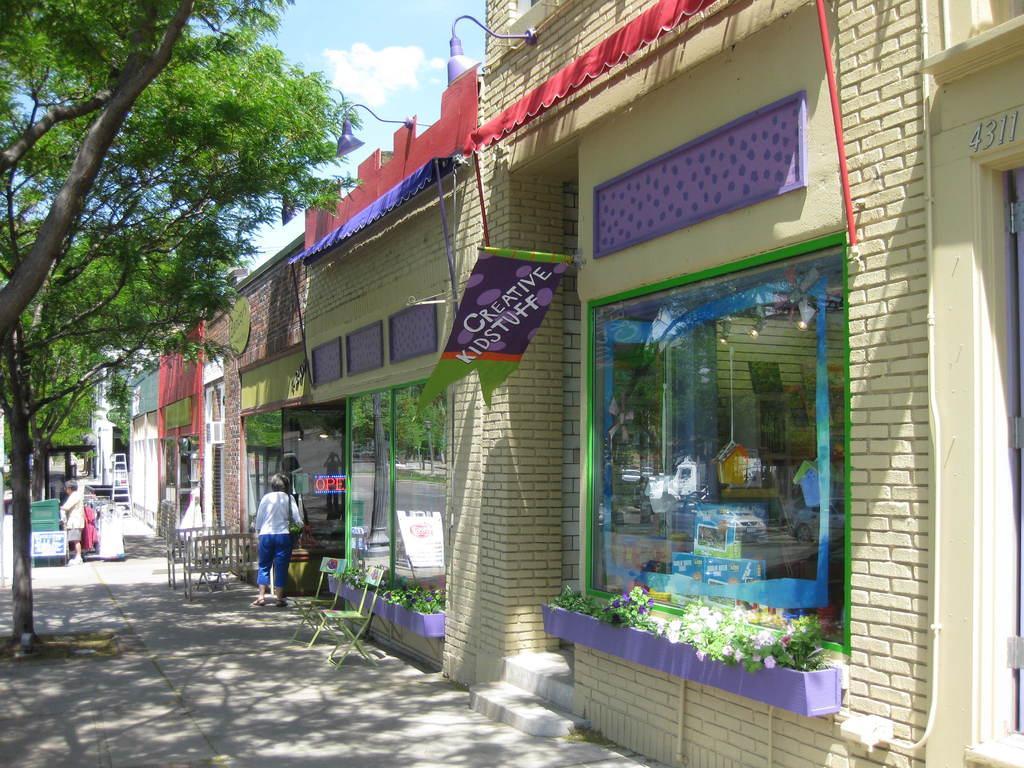In one or two sentences, can you explain what this image depicts? In this image we can see building, chairs, benches, persons, ladder, trees, plants, sky and clouds. 